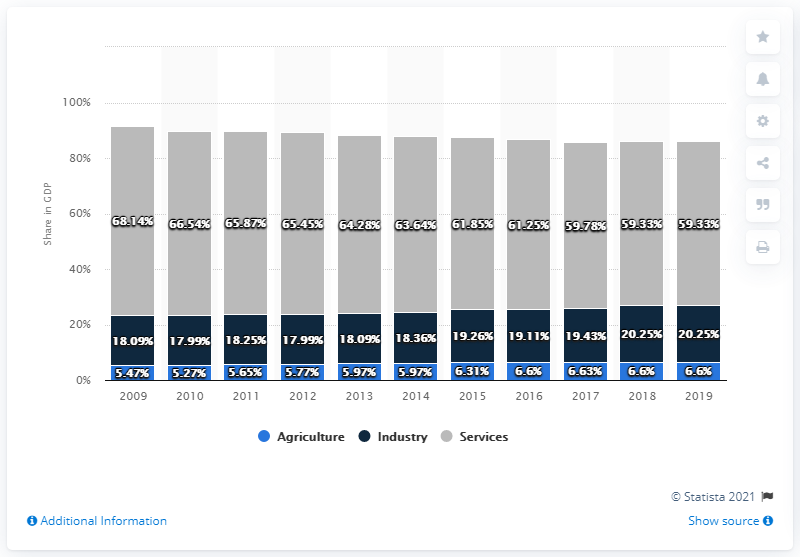Draw attention to some important aspects in this diagram. In 2019, the share of agriculture in Jamaica's gross domestic product (GDP) was 6.6%. 